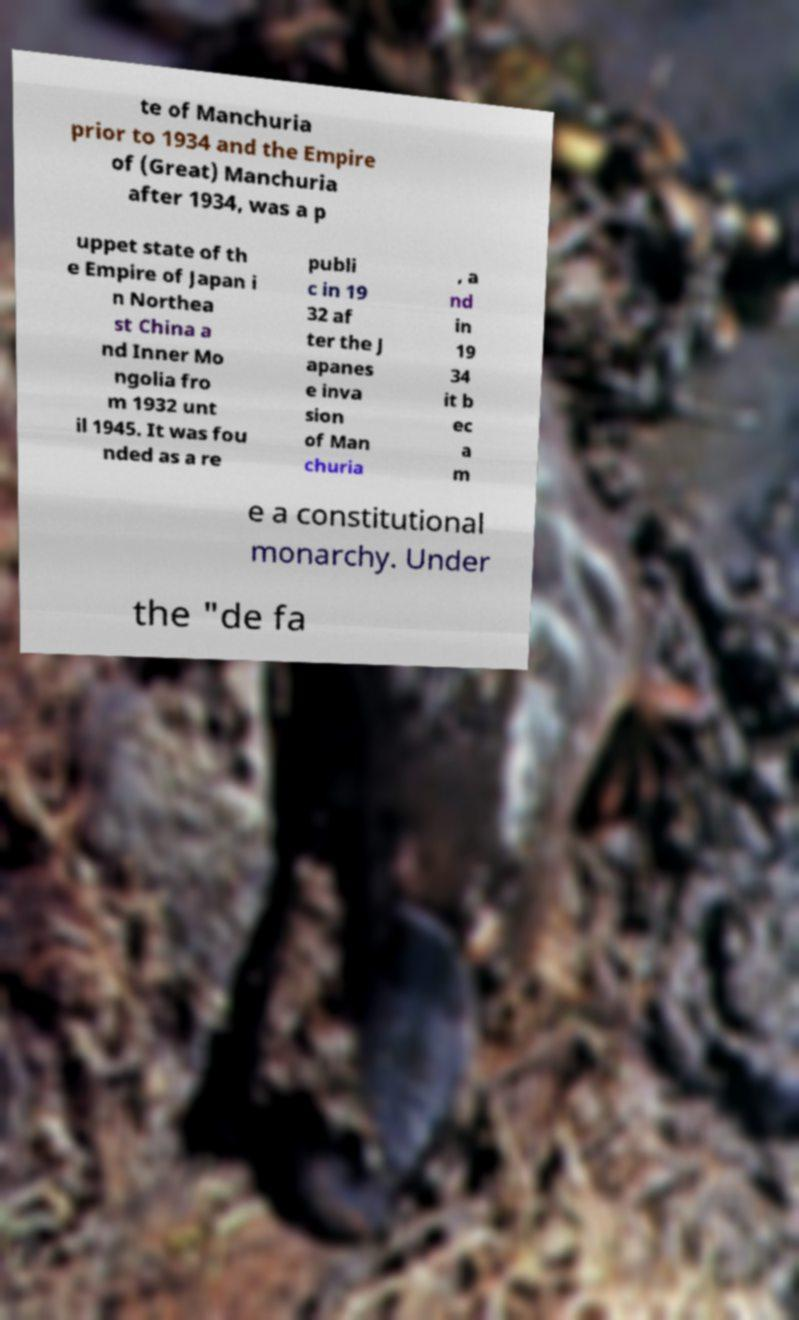Please identify and transcribe the text found in this image. te of Manchuria prior to 1934 and the Empire of (Great) Manchuria after 1934, was a p uppet state of th e Empire of Japan i n Northea st China a nd Inner Mo ngolia fro m 1932 unt il 1945. It was fou nded as a re publi c in 19 32 af ter the J apanes e inva sion of Man churia , a nd in 19 34 it b ec a m e a constitutional monarchy. Under the "de fa 